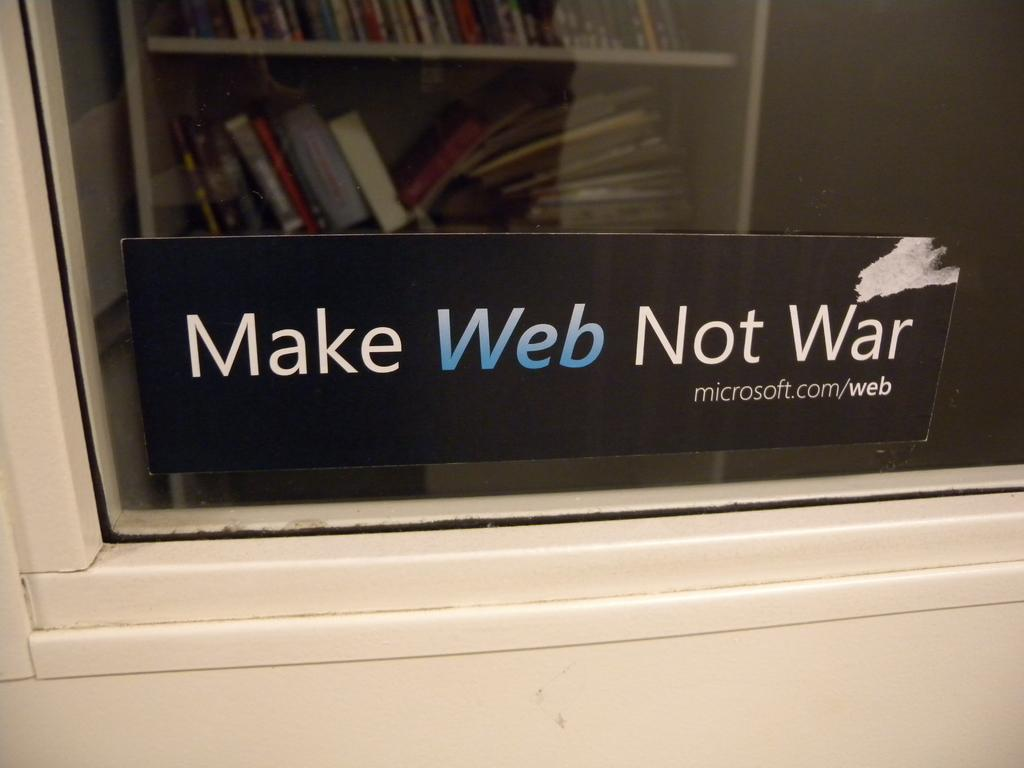<image>
Write a terse but informative summary of the picture. A window sticker for Microsoft that reads make web not war. 